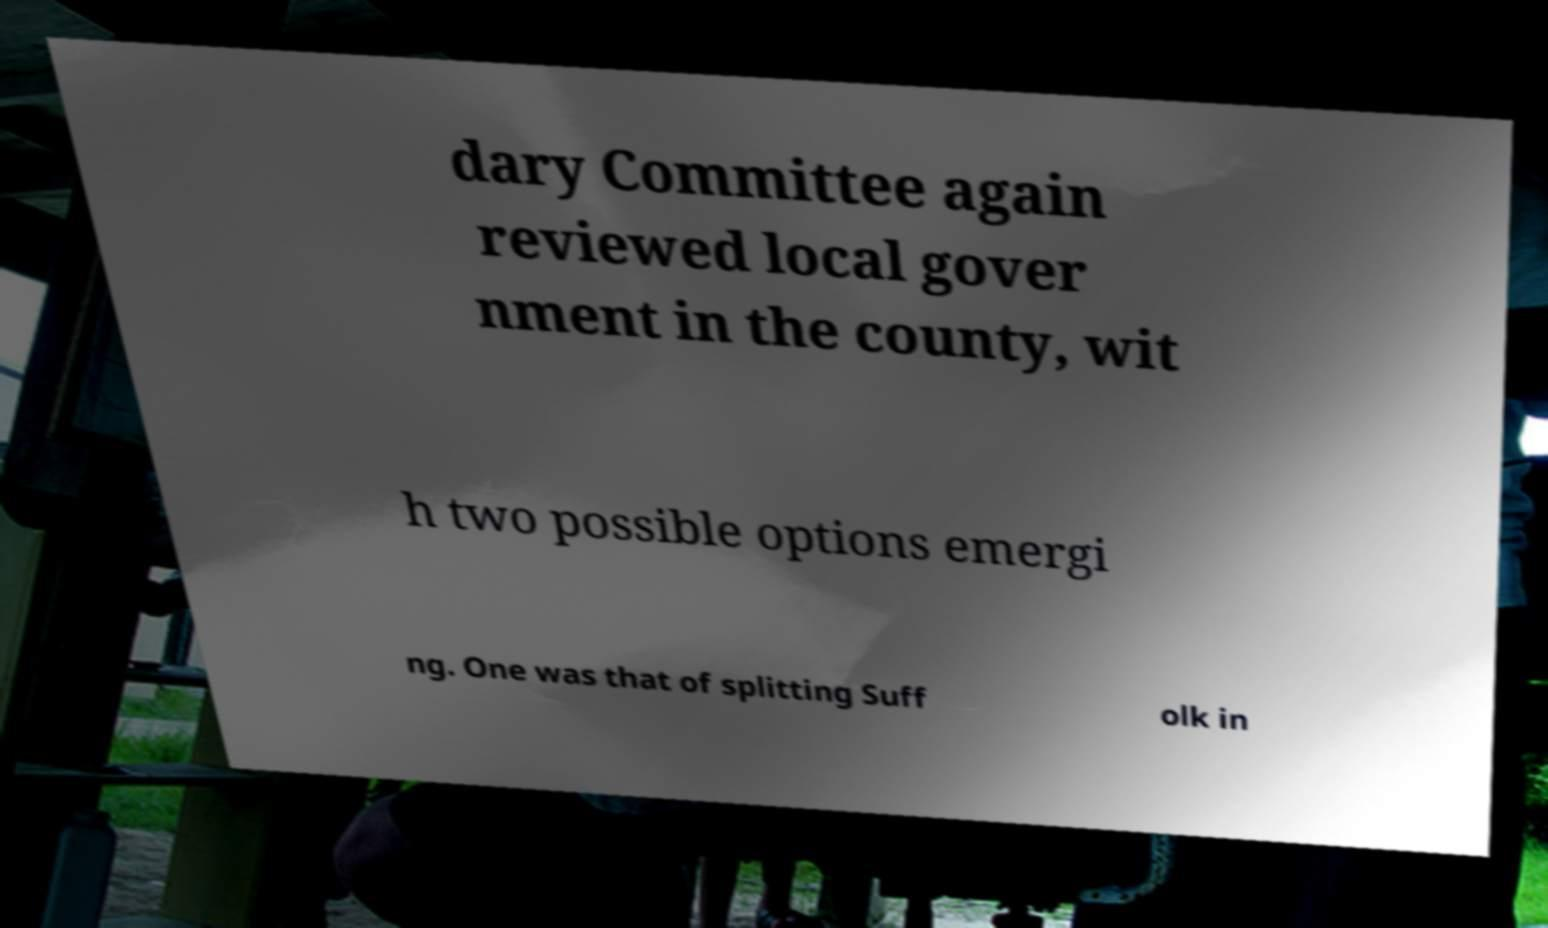Please identify and transcribe the text found in this image. dary Committee again reviewed local gover nment in the county, wit h two possible options emergi ng. One was that of splitting Suff olk in 